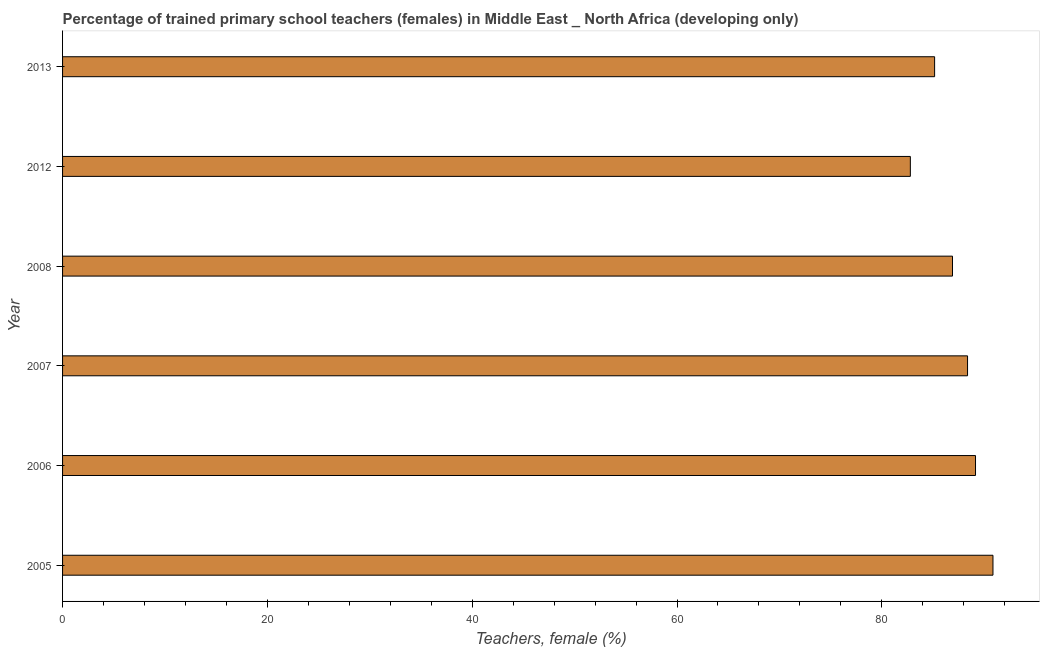Does the graph contain any zero values?
Keep it short and to the point. No. Does the graph contain grids?
Ensure brevity in your answer.  No. What is the title of the graph?
Your answer should be compact. Percentage of trained primary school teachers (females) in Middle East _ North Africa (developing only). What is the label or title of the X-axis?
Your answer should be compact. Teachers, female (%). What is the label or title of the Y-axis?
Provide a succinct answer. Year. What is the percentage of trained female teachers in 2008?
Your answer should be compact. 86.9. Across all years, what is the maximum percentage of trained female teachers?
Your response must be concise. 90.85. Across all years, what is the minimum percentage of trained female teachers?
Make the answer very short. 82.79. What is the sum of the percentage of trained female teachers?
Ensure brevity in your answer.  523.22. What is the difference between the percentage of trained female teachers in 2007 and 2008?
Give a very brief answer. 1.47. What is the average percentage of trained female teachers per year?
Your answer should be compact. 87.2. What is the median percentage of trained female teachers?
Make the answer very short. 87.64. In how many years, is the percentage of trained female teachers greater than 48 %?
Provide a short and direct response. 6. Do a majority of the years between 2006 and 2012 (inclusive) have percentage of trained female teachers greater than 80 %?
Make the answer very short. Yes. What is the ratio of the percentage of trained female teachers in 2006 to that in 2013?
Your answer should be very brief. 1.05. Is the difference between the percentage of trained female teachers in 2005 and 2012 greater than the difference between any two years?
Your response must be concise. Yes. What is the difference between the highest and the second highest percentage of trained female teachers?
Make the answer very short. 1.7. Is the sum of the percentage of trained female teachers in 2006 and 2013 greater than the maximum percentage of trained female teachers across all years?
Make the answer very short. Yes. What is the difference between the highest and the lowest percentage of trained female teachers?
Offer a terse response. 8.07. In how many years, is the percentage of trained female teachers greater than the average percentage of trained female teachers taken over all years?
Keep it short and to the point. 3. How many bars are there?
Offer a very short reply. 6. Are all the bars in the graph horizontal?
Make the answer very short. Yes. How many years are there in the graph?
Make the answer very short. 6. What is the Teachers, female (%) in 2005?
Your response must be concise. 90.85. What is the Teachers, female (%) in 2006?
Give a very brief answer. 89.15. What is the Teachers, female (%) of 2007?
Your answer should be compact. 88.37. What is the Teachers, female (%) of 2008?
Provide a succinct answer. 86.9. What is the Teachers, female (%) of 2012?
Provide a short and direct response. 82.79. What is the Teachers, female (%) of 2013?
Give a very brief answer. 85.15. What is the difference between the Teachers, female (%) in 2005 and 2006?
Ensure brevity in your answer.  1.7. What is the difference between the Teachers, female (%) in 2005 and 2007?
Offer a terse response. 2.48. What is the difference between the Teachers, female (%) in 2005 and 2008?
Offer a very short reply. 3.95. What is the difference between the Teachers, female (%) in 2005 and 2012?
Provide a short and direct response. 8.07. What is the difference between the Teachers, female (%) in 2005 and 2013?
Provide a short and direct response. 5.7. What is the difference between the Teachers, female (%) in 2006 and 2007?
Offer a terse response. 0.78. What is the difference between the Teachers, female (%) in 2006 and 2008?
Keep it short and to the point. 2.25. What is the difference between the Teachers, female (%) in 2006 and 2012?
Give a very brief answer. 6.36. What is the difference between the Teachers, female (%) in 2006 and 2013?
Your answer should be compact. 4. What is the difference between the Teachers, female (%) in 2007 and 2008?
Your answer should be very brief. 1.47. What is the difference between the Teachers, female (%) in 2007 and 2012?
Your response must be concise. 5.59. What is the difference between the Teachers, female (%) in 2007 and 2013?
Offer a very short reply. 3.22. What is the difference between the Teachers, female (%) in 2008 and 2012?
Provide a short and direct response. 4.12. What is the difference between the Teachers, female (%) in 2008 and 2013?
Your answer should be very brief. 1.75. What is the difference between the Teachers, female (%) in 2012 and 2013?
Your response must be concise. -2.37. What is the ratio of the Teachers, female (%) in 2005 to that in 2007?
Keep it short and to the point. 1.03. What is the ratio of the Teachers, female (%) in 2005 to that in 2008?
Offer a terse response. 1.04. What is the ratio of the Teachers, female (%) in 2005 to that in 2012?
Provide a succinct answer. 1.1. What is the ratio of the Teachers, female (%) in 2005 to that in 2013?
Provide a short and direct response. 1.07. What is the ratio of the Teachers, female (%) in 2006 to that in 2007?
Your response must be concise. 1.01. What is the ratio of the Teachers, female (%) in 2006 to that in 2012?
Provide a short and direct response. 1.08. What is the ratio of the Teachers, female (%) in 2006 to that in 2013?
Ensure brevity in your answer.  1.05. What is the ratio of the Teachers, female (%) in 2007 to that in 2012?
Offer a very short reply. 1.07. What is the ratio of the Teachers, female (%) in 2007 to that in 2013?
Your answer should be compact. 1.04. 